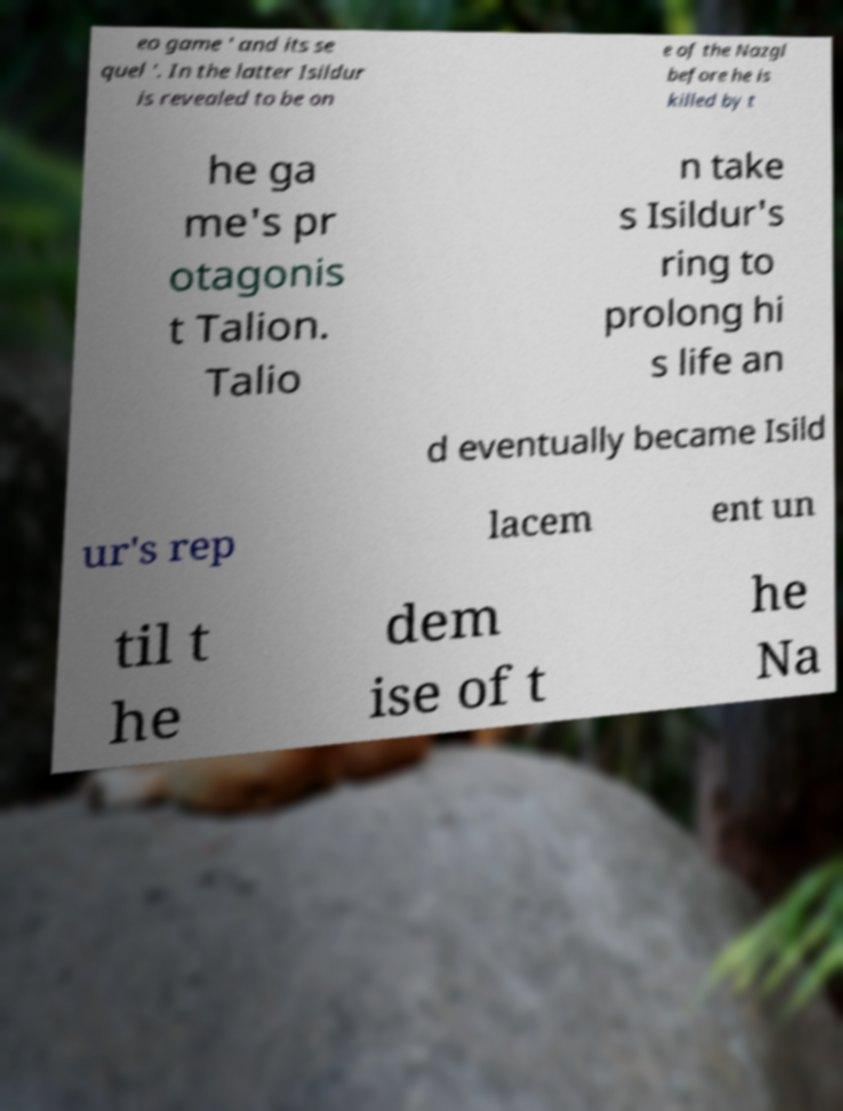There's text embedded in this image that I need extracted. Can you transcribe it verbatim? eo game ' and its se quel '. In the latter Isildur is revealed to be on e of the Nazgl before he is killed by t he ga me's pr otagonis t Talion. Talio n take s Isildur's ring to prolong hi s life an d eventually became Isild ur's rep lacem ent un til t he dem ise of t he Na 